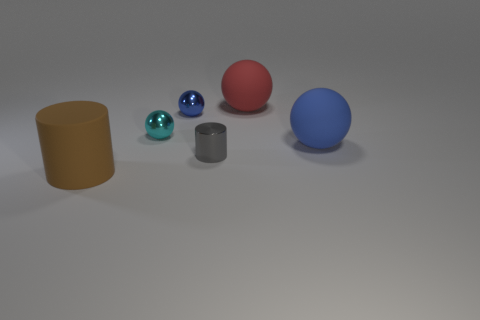Subtract all cyan balls. How many balls are left? 3 Add 4 tiny red rubber balls. How many objects exist? 10 Subtract all cylinders. How many objects are left? 4 Add 6 large spheres. How many large spheres exist? 8 Subtract 0 purple cylinders. How many objects are left? 6 Subtract all large brown rubber objects. Subtract all large brown objects. How many objects are left? 4 Add 3 large blue things. How many large blue things are left? 4 